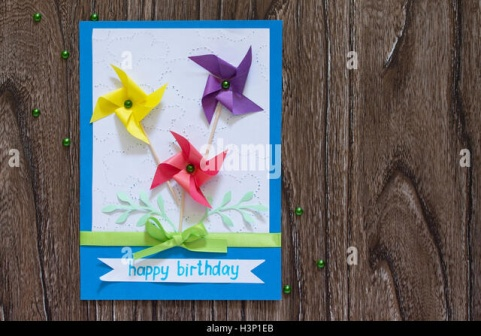Imagine the green ribbon on the card could speak. What story would it tell? If the green ribbon on the card could speak, it would tell a tale of wishes and dreams. It would share the story of how it once adorned a magical birthday cake in a faraway land, where each slice granted the birthday child a wish. The ribbon, filled with mystical energy from years of tying around special gifts and treasures, has whispered countless secrets and desires. Now, as it rests on this birthday card, it brings a touch of that magic to the celebration, ready to make another wish come true. What kind of artistic techniques might have been used to create the card's design? The card's design likely involves a combination of several artistic techniques. The crisp blue border and white center suggest the use of precision cutting and layering of quality cardstock. The elegant inscription of 'happy birthday' might be achieved through calligraphy or digital printing, ensuring a flawless presentation. The pinwheels are beautifully crafted, possibly through origami or hand-cut and assembled pieces, adding a three-dimensional element to the card. The green ribbon is carefully tied, indicating a skillful touch in crafting. Lastly, the scattering of green beads is a playful yet thoughtful embellishment, possibly applied using adhesive techniques to keep them securely in place, resulting in a delightful and festive greeting card. 